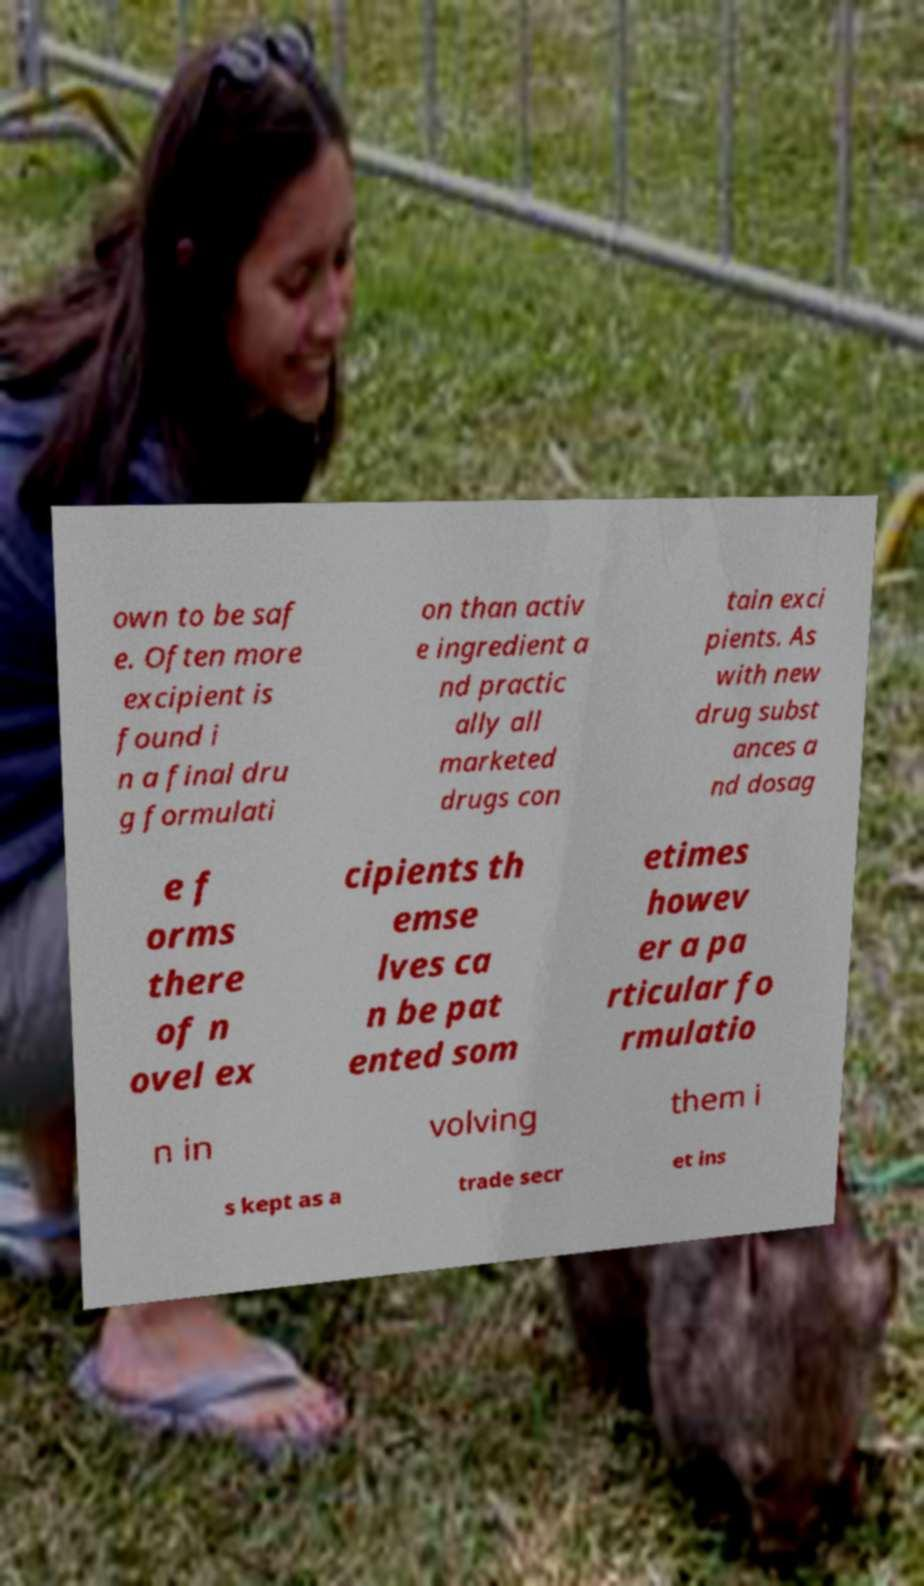Could you assist in decoding the text presented in this image and type it out clearly? own to be saf e. Often more excipient is found i n a final dru g formulati on than activ e ingredient a nd practic ally all marketed drugs con tain exci pients. As with new drug subst ances a nd dosag e f orms there of n ovel ex cipients th emse lves ca n be pat ented som etimes howev er a pa rticular fo rmulatio n in volving them i s kept as a trade secr et ins 